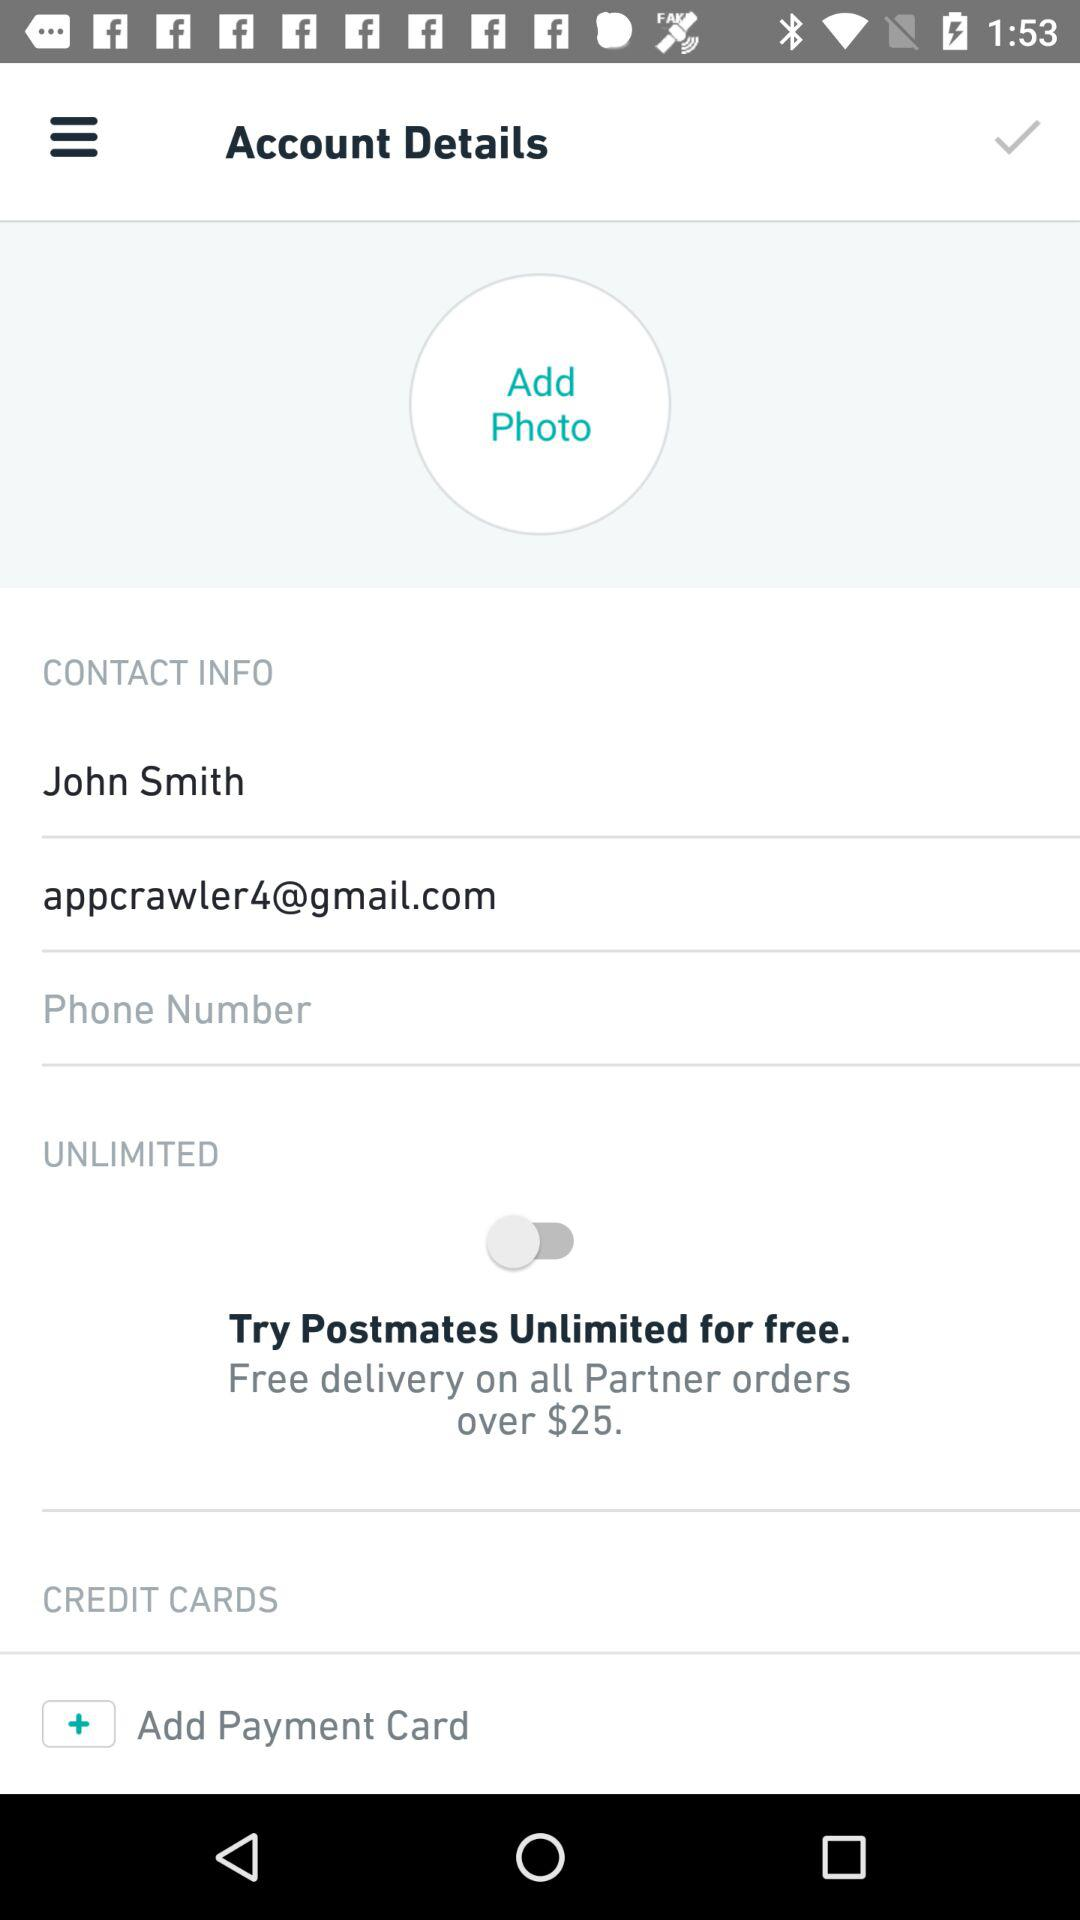What is the name of the user? The name of the user is John Smith. 